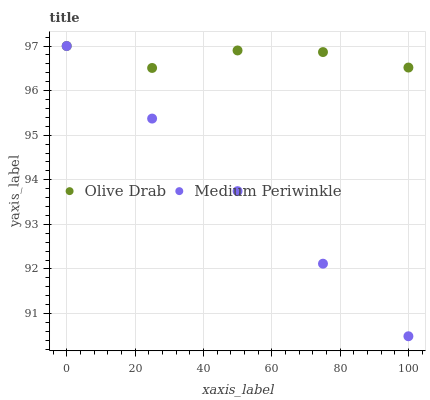Does Medium Periwinkle have the minimum area under the curve?
Answer yes or no. Yes. Does Olive Drab have the maximum area under the curve?
Answer yes or no. Yes. Does Olive Drab have the minimum area under the curve?
Answer yes or no. No. Is Medium Periwinkle the smoothest?
Answer yes or no. Yes. Is Olive Drab the roughest?
Answer yes or no. Yes. Is Olive Drab the smoothest?
Answer yes or no. No. Does Medium Periwinkle have the lowest value?
Answer yes or no. Yes. Does Olive Drab have the lowest value?
Answer yes or no. No. Does Olive Drab have the highest value?
Answer yes or no. Yes. Does Olive Drab intersect Medium Periwinkle?
Answer yes or no. Yes. Is Olive Drab less than Medium Periwinkle?
Answer yes or no. No. Is Olive Drab greater than Medium Periwinkle?
Answer yes or no. No. 